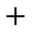<formula> <loc_0><loc_0><loc_500><loc_500>^ { + }</formula> 